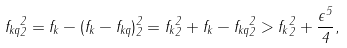Convert formula to latex. <formula><loc_0><loc_0><loc_500><loc_500>\| f _ { k q } \| _ { 2 } ^ { 2 } = \| f _ { k } - ( f _ { k } - f _ { k q } ) \| _ { 2 } ^ { 2 } = \| f _ { k } \| _ { 2 } ^ { 2 } + \| f _ { k } - f _ { k q } \| _ { 2 } ^ { 2 } > \| f _ { k } \| _ { 2 } ^ { 2 } + \frac { \epsilon ^ { 5 } } { 4 } ,</formula> 